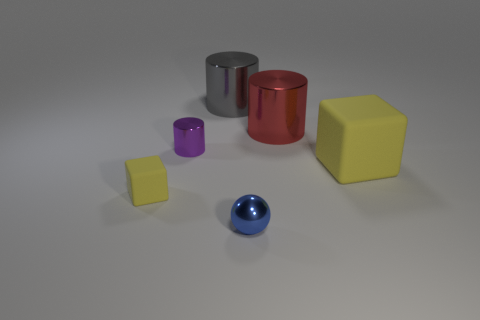What material is the blue ball that is the same size as the purple thing?
Keep it short and to the point. Metal. What number of green things are tiny shiny cylinders or small matte blocks?
Offer a very short reply. 0. The thing that is both in front of the small purple shiny thing and to the right of the small blue metal ball is what color?
Ensure brevity in your answer.  Yellow. Does the object that is behind the large red cylinder have the same material as the yellow cube to the left of the tiny metal cylinder?
Provide a short and direct response. No. Is the number of red metal cylinders behind the blue metallic ball greater than the number of big yellow objects in front of the tiny rubber cube?
Provide a short and direct response. Yes. What is the shape of the yellow matte object that is the same size as the purple cylinder?
Make the answer very short. Cube. How many objects are big red rubber cylinders or large objects to the left of the blue sphere?
Make the answer very short. 1. Does the large matte cube have the same color as the ball?
Your response must be concise. No. There is a red metal thing; how many rubber cubes are behind it?
Your response must be concise. 0. There is a small ball that is the same material as the tiny purple object; what color is it?
Ensure brevity in your answer.  Blue. 